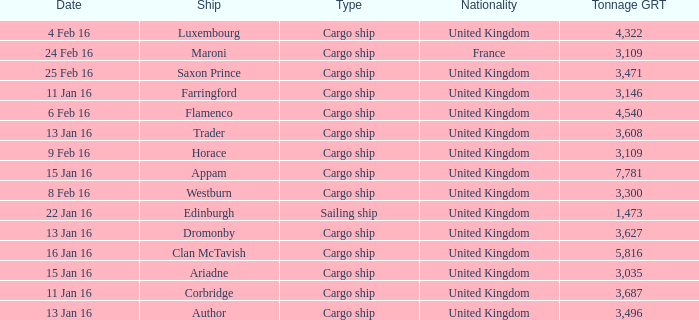Give me the full table as a dictionary. {'header': ['Date', 'Ship', 'Type', 'Nationality', 'Tonnage GRT'], 'rows': [['4 Feb 16', 'Luxembourg', 'Cargo ship', 'United Kingdom', '4,322'], ['24 Feb 16', 'Maroni', 'Cargo ship', 'France', '3,109'], ['25 Feb 16', 'Saxon Prince', 'Cargo ship', 'United Kingdom', '3,471'], ['11 Jan 16', 'Farringford', 'Cargo ship', 'United Kingdom', '3,146'], ['6 Feb 16', 'Flamenco', 'Cargo ship', 'United Kingdom', '4,540'], ['13 Jan 16', 'Trader', 'Cargo ship', 'United Kingdom', '3,608'], ['9 Feb 16', 'Horace', 'Cargo ship', 'United Kingdom', '3,109'], ['15 Jan 16', 'Appam', 'Cargo ship', 'United Kingdom', '7,781'], ['8 Feb 16', 'Westburn', 'Cargo ship', 'United Kingdom', '3,300'], ['22 Jan 16', 'Edinburgh', 'Sailing ship', 'United Kingdom', '1,473'], ['13 Jan 16', 'Dromonby', 'Cargo ship', 'United Kingdom', '3,627'], ['16 Jan 16', 'Clan McTavish', 'Cargo ship', 'United Kingdom', '5,816'], ['15 Jan 16', 'Ariadne', 'Cargo ship', 'United Kingdom', '3,035'], ['11 Jan 16', 'Corbridge', 'Cargo ship', 'United Kingdom', '3,687'], ['13 Jan 16', 'Author', 'Cargo ship', 'United Kingdom', '3,496']]} What is the most tonnage grt of any ship sunk or captured on 16 jan 16? 5816.0. 